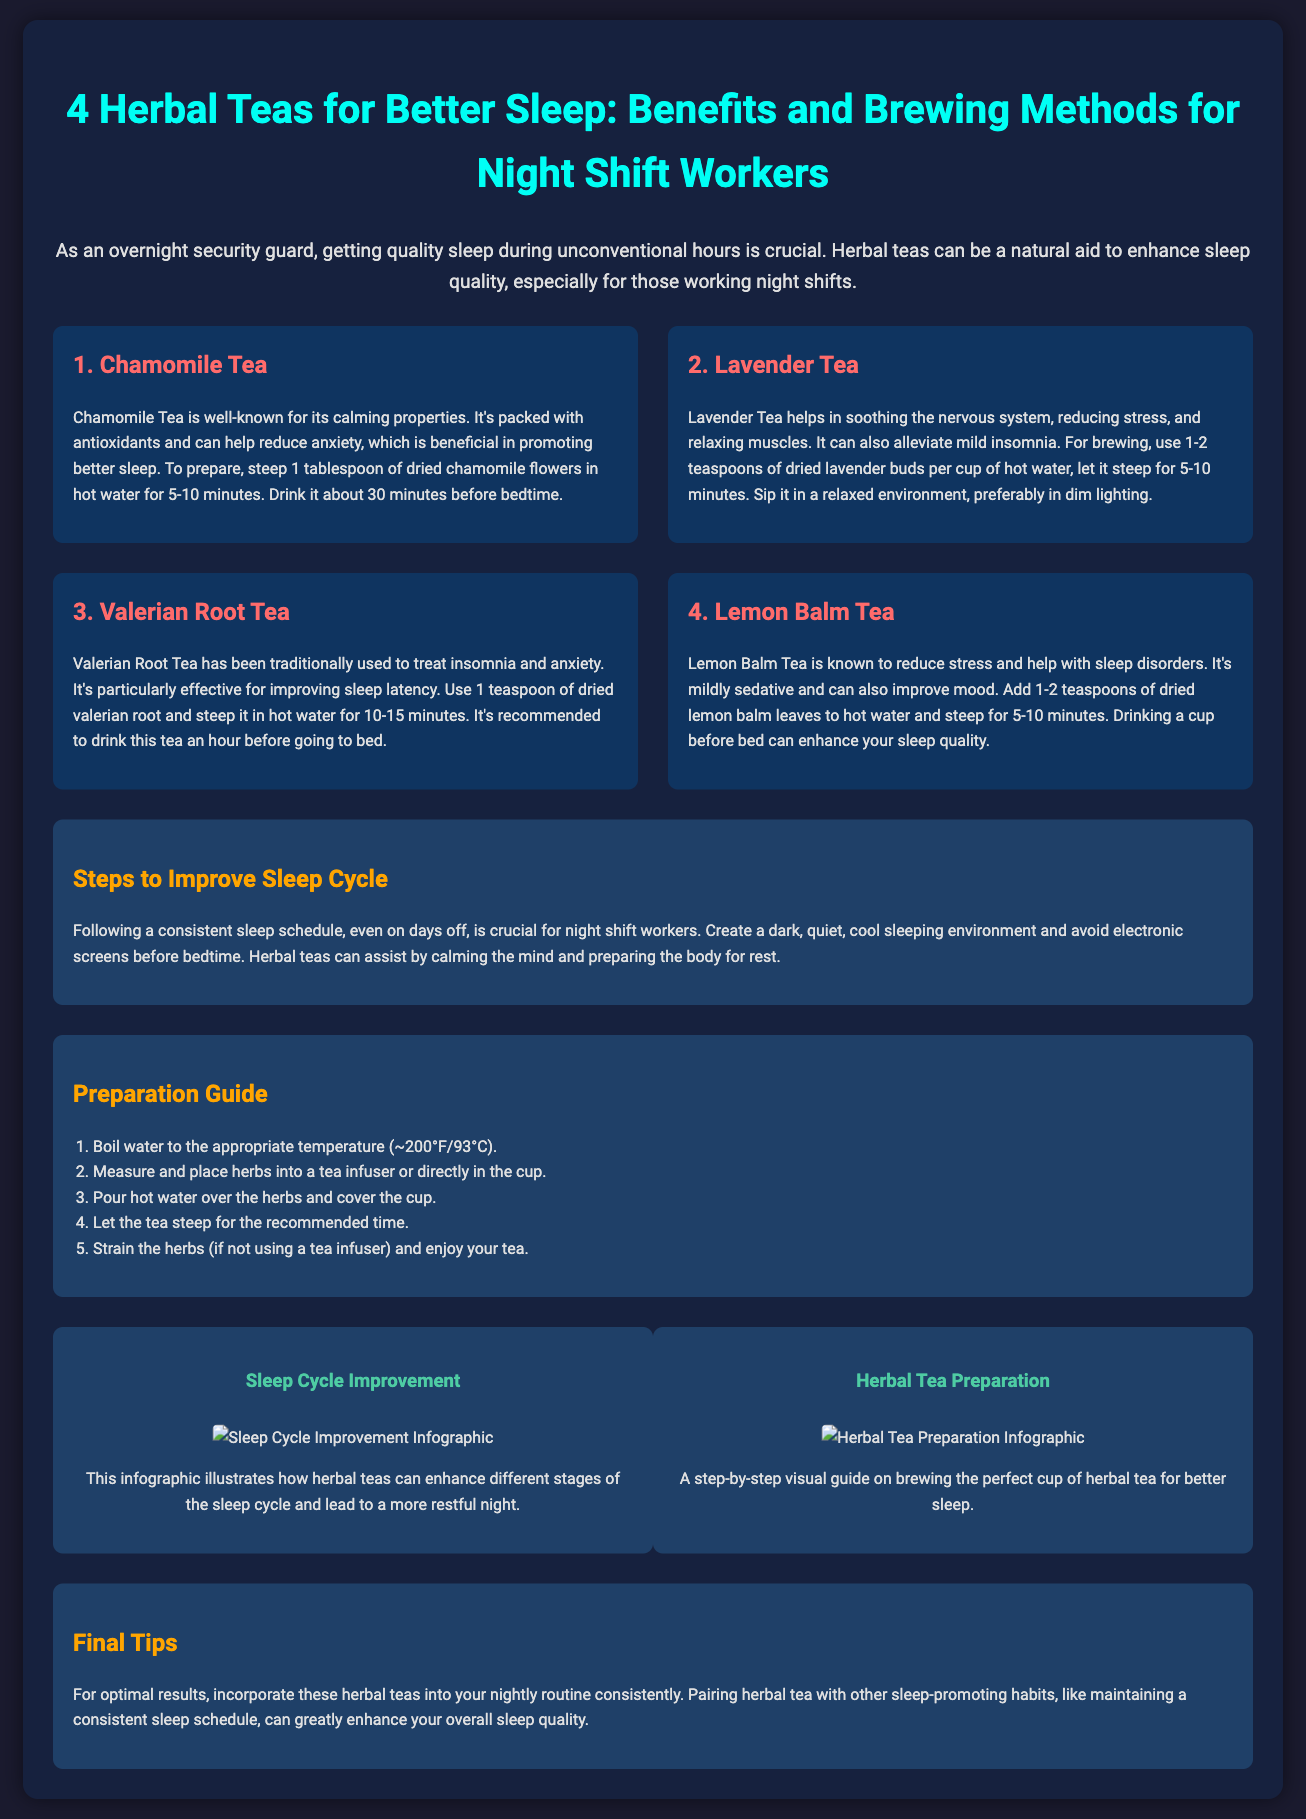what is the name of the first herbal tea listed? The document states that the first herbal tea is Chamomile Tea, noted for its calming properties.
Answer: Chamomile Tea how long should chamomile tea steep? The preparation information mentions steeping time for chamomile tea is between 5 to 10 minutes.
Answer: 5-10 minutes which herbal tea is effective for insomnia? The document identifies Valerian Root Tea as traditionally used to treat insomnia.
Answer: Valerian Root Tea how many herbal teas are illustrated in the document? The document lists and describes four herbal teas to aid in better sleep.
Answer: Four what temperature should water be for brewing? The preparation guide specifies that the water temperature should be around 200°F or 93°C.
Answer: 200°F how often should herbal teas be incorporated into a nightly routine? The document suggests that for optimal results, herbal teas should be consistently incorporated into the nightly routine.
Answer: Consistently what color is the background of the document? The document's background color is described as a dark color, specifically #1a1a2e.
Answer: Dark what are the final tips for better sleep mentioned? The final tips section emphasizes maintaining a consistent sleep schedule alongside herbal tea consumption.
Answer: Consistent sleep schedule how many steps are in the preparation guide? The preparation guide lists five steps for making herbal tea.
Answer: Five 